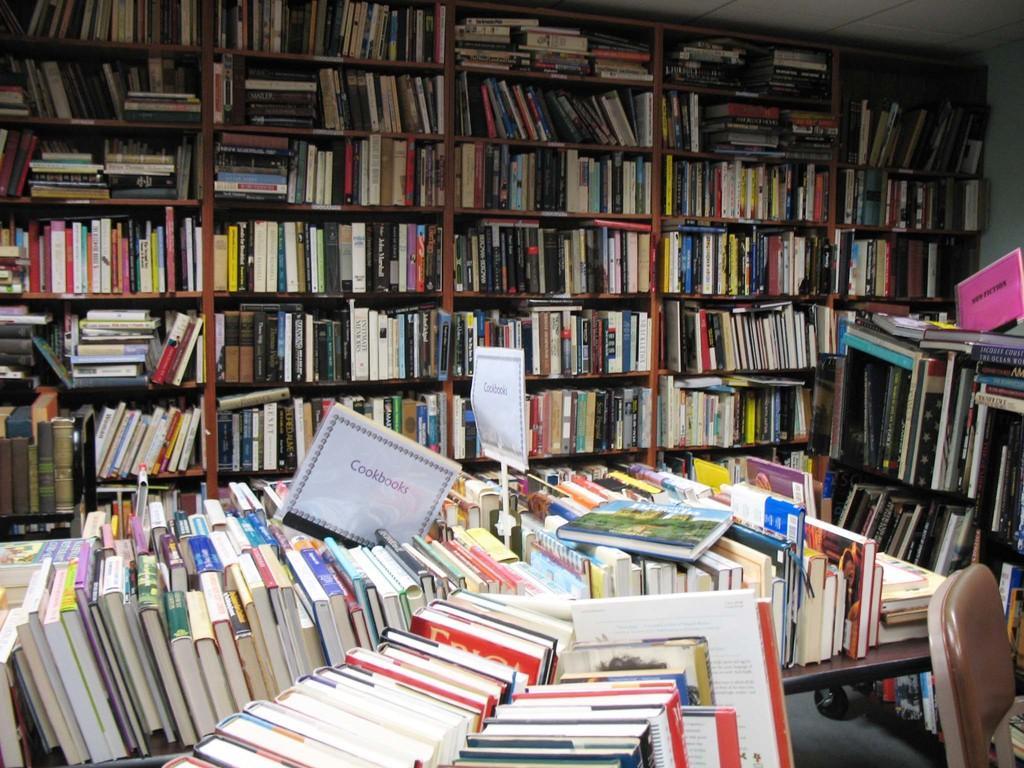Can you describe this image briefly? In this picture I can see placards and there are so many books arranged in an order on the table, there is a chair, and in the background there are books arranged in an order in the racks. 